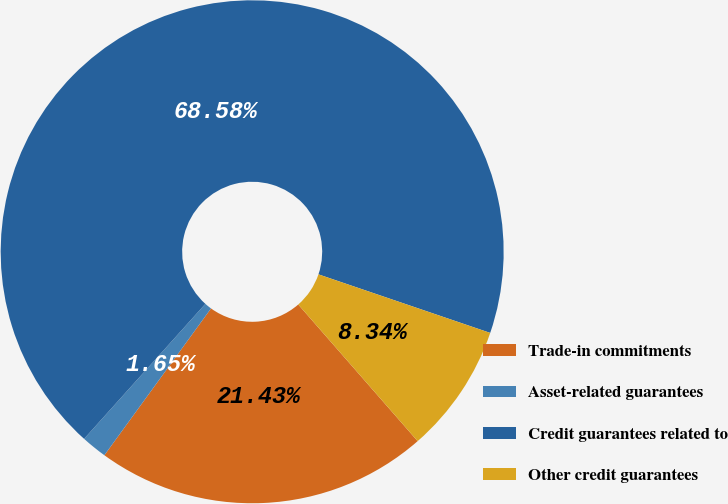<chart> <loc_0><loc_0><loc_500><loc_500><pie_chart><fcel>Trade-in commitments<fcel>Asset-related guarantees<fcel>Credit guarantees related to<fcel>Other credit guarantees<nl><fcel>21.43%<fcel>1.65%<fcel>68.58%<fcel>8.34%<nl></chart> 